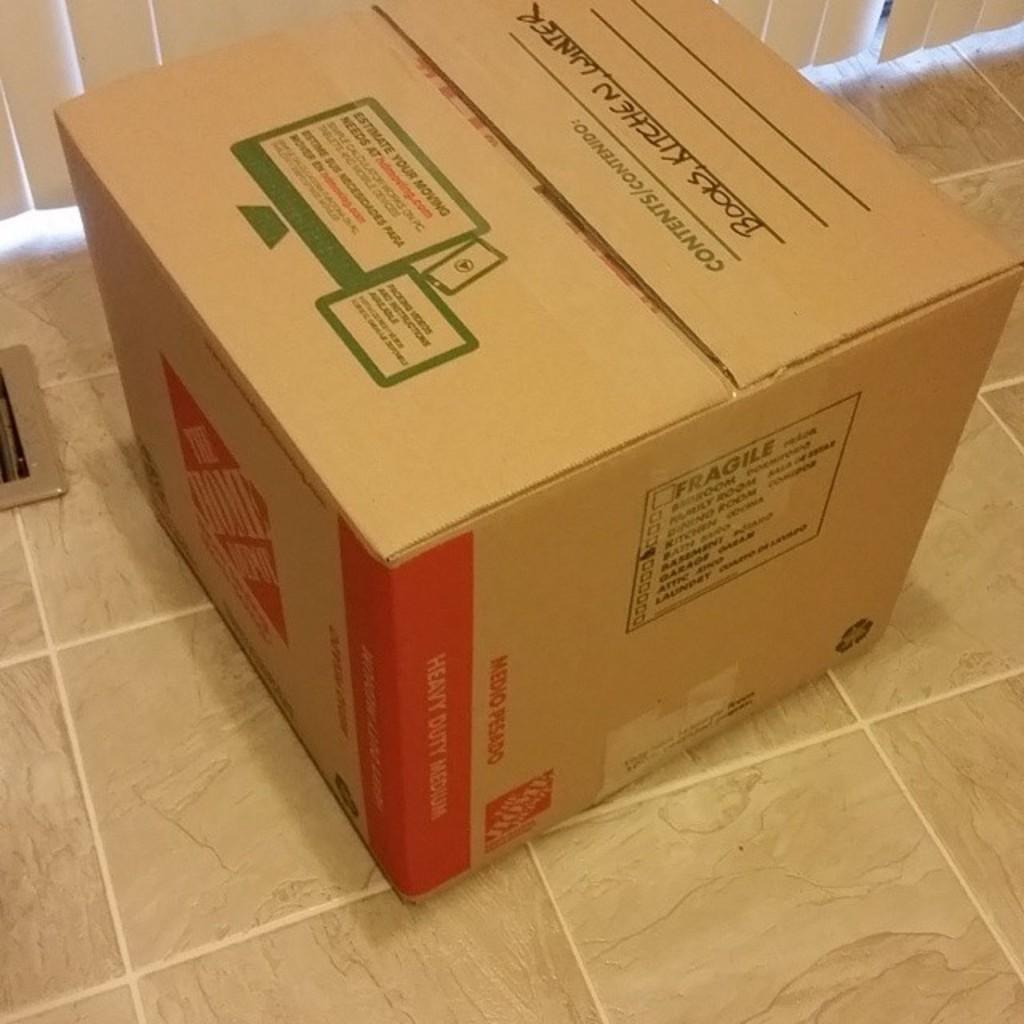<image>
Offer a succinct explanation of the picture presented. home depot cardboard box containing books, kitchen , and winter items 